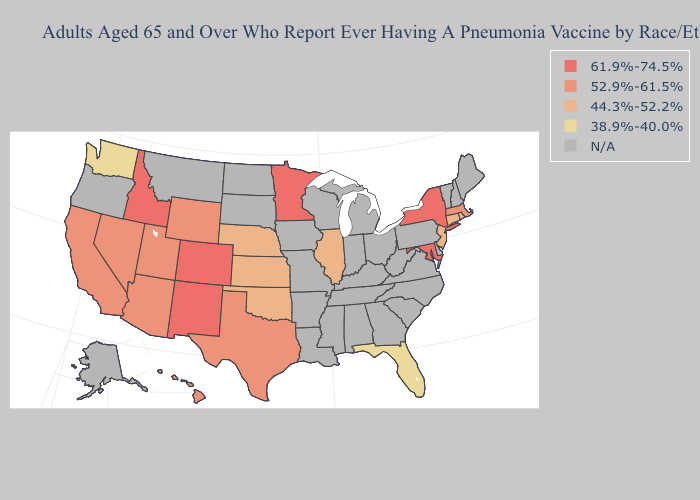What is the lowest value in the West?
Answer briefly. 38.9%-40.0%. Among the states that border Arizona , which have the highest value?
Short answer required. Colorado, New Mexico. Does Rhode Island have the lowest value in the USA?
Quick response, please. No. What is the value of New Jersey?
Keep it brief. 44.3%-52.2%. What is the highest value in the Northeast ?
Quick response, please. 61.9%-74.5%. Which states hav the highest value in the South?
Write a very short answer. Maryland. What is the value of Missouri?
Short answer required. N/A. What is the highest value in states that border Iowa?
Answer briefly. 61.9%-74.5%. Does the map have missing data?
Short answer required. Yes. What is the value of Idaho?
Quick response, please. 61.9%-74.5%. What is the value of California?
Concise answer only. 52.9%-61.5%. Name the states that have a value in the range 61.9%-74.5%?
Keep it brief. Colorado, Idaho, Maryland, Minnesota, New Mexico, New York. Name the states that have a value in the range 61.9%-74.5%?
Keep it brief. Colorado, Idaho, Maryland, Minnesota, New Mexico, New York. Name the states that have a value in the range 38.9%-40.0%?
Answer briefly. Florida, Washington. Name the states that have a value in the range 44.3%-52.2%?
Quick response, please. Connecticut, Illinois, Kansas, Nebraska, New Jersey, Oklahoma, Rhode Island. 